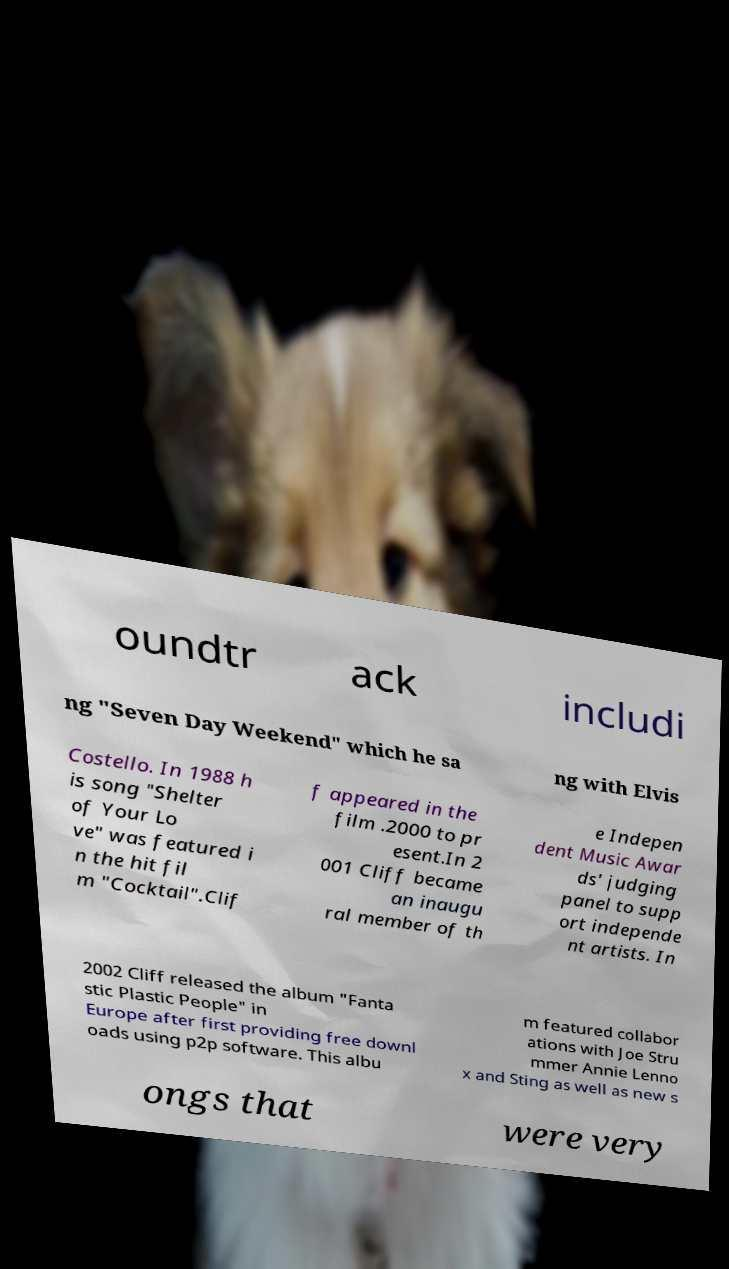Can you accurately transcribe the text from the provided image for me? oundtr ack includi ng "Seven Day Weekend" which he sa ng with Elvis Costello. In 1988 h is song "Shelter of Your Lo ve" was featured i n the hit fil m "Cocktail".Clif f appeared in the film .2000 to pr esent.In 2 001 Cliff became an inaugu ral member of th e Indepen dent Music Awar ds' judging panel to supp ort independe nt artists. In 2002 Cliff released the album "Fanta stic Plastic People" in Europe after first providing free downl oads using p2p software. This albu m featured collabor ations with Joe Stru mmer Annie Lenno x and Sting as well as new s ongs that were very 